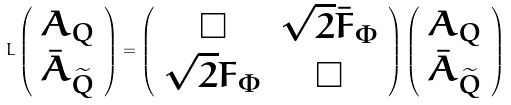Convert formula to latex. <formula><loc_0><loc_0><loc_500><loc_500>L \left ( \begin{array} { c } A _ { Q } \\ \bar { A } _ { \widetilde { Q } } \end{array} \right ) = \left ( \begin{array} { c c } \Box & \sqrt { 2 } \bar { F } _ { \Phi } \\ \sqrt { 2 } F _ { \Phi } & \Box \end{array} \right ) \left ( \begin{array} { c } A _ { Q } \\ \bar { A } _ { \widetilde { Q } } \end{array} \right )</formula> 